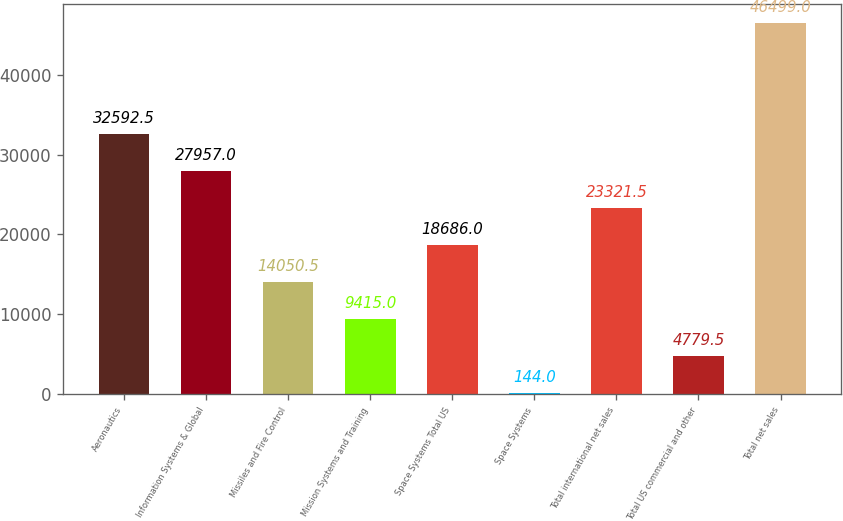<chart> <loc_0><loc_0><loc_500><loc_500><bar_chart><fcel>Aeronautics<fcel>Information Systems & Global<fcel>Missiles and Fire Control<fcel>Mission Systems and Training<fcel>Space Systems Total US<fcel>Space Systems<fcel>Total international net sales<fcel>Total US commercial and other<fcel>Total net sales<nl><fcel>32592.5<fcel>27957<fcel>14050.5<fcel>9415<fcel>18686<fcel>144<fcel>23321.5<fcel>4779.5<fcel>46499<nl></chart> 